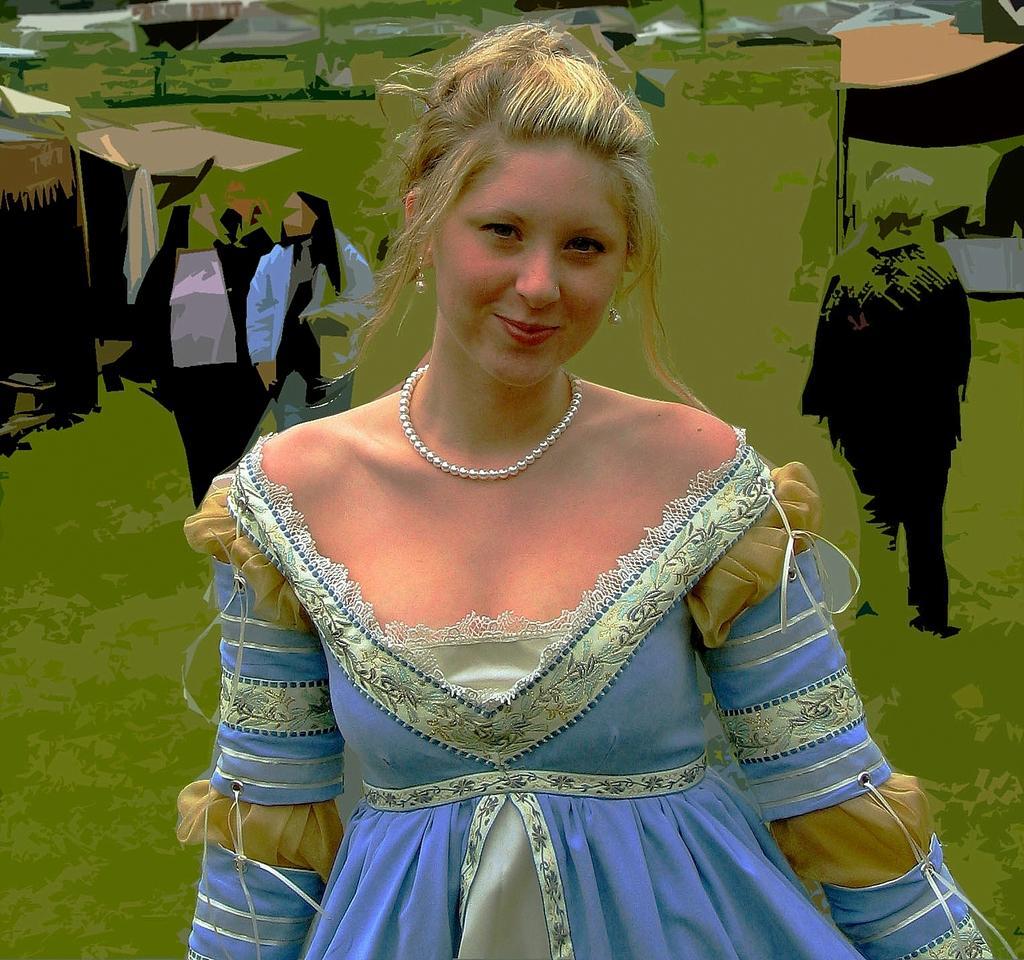In one or two sentences, can you explain what this image depicts? There is a woman in blue color dress smiling and standing. In the background, there is a painting in which, there are persons on the grass on the ground and there are other objects. 